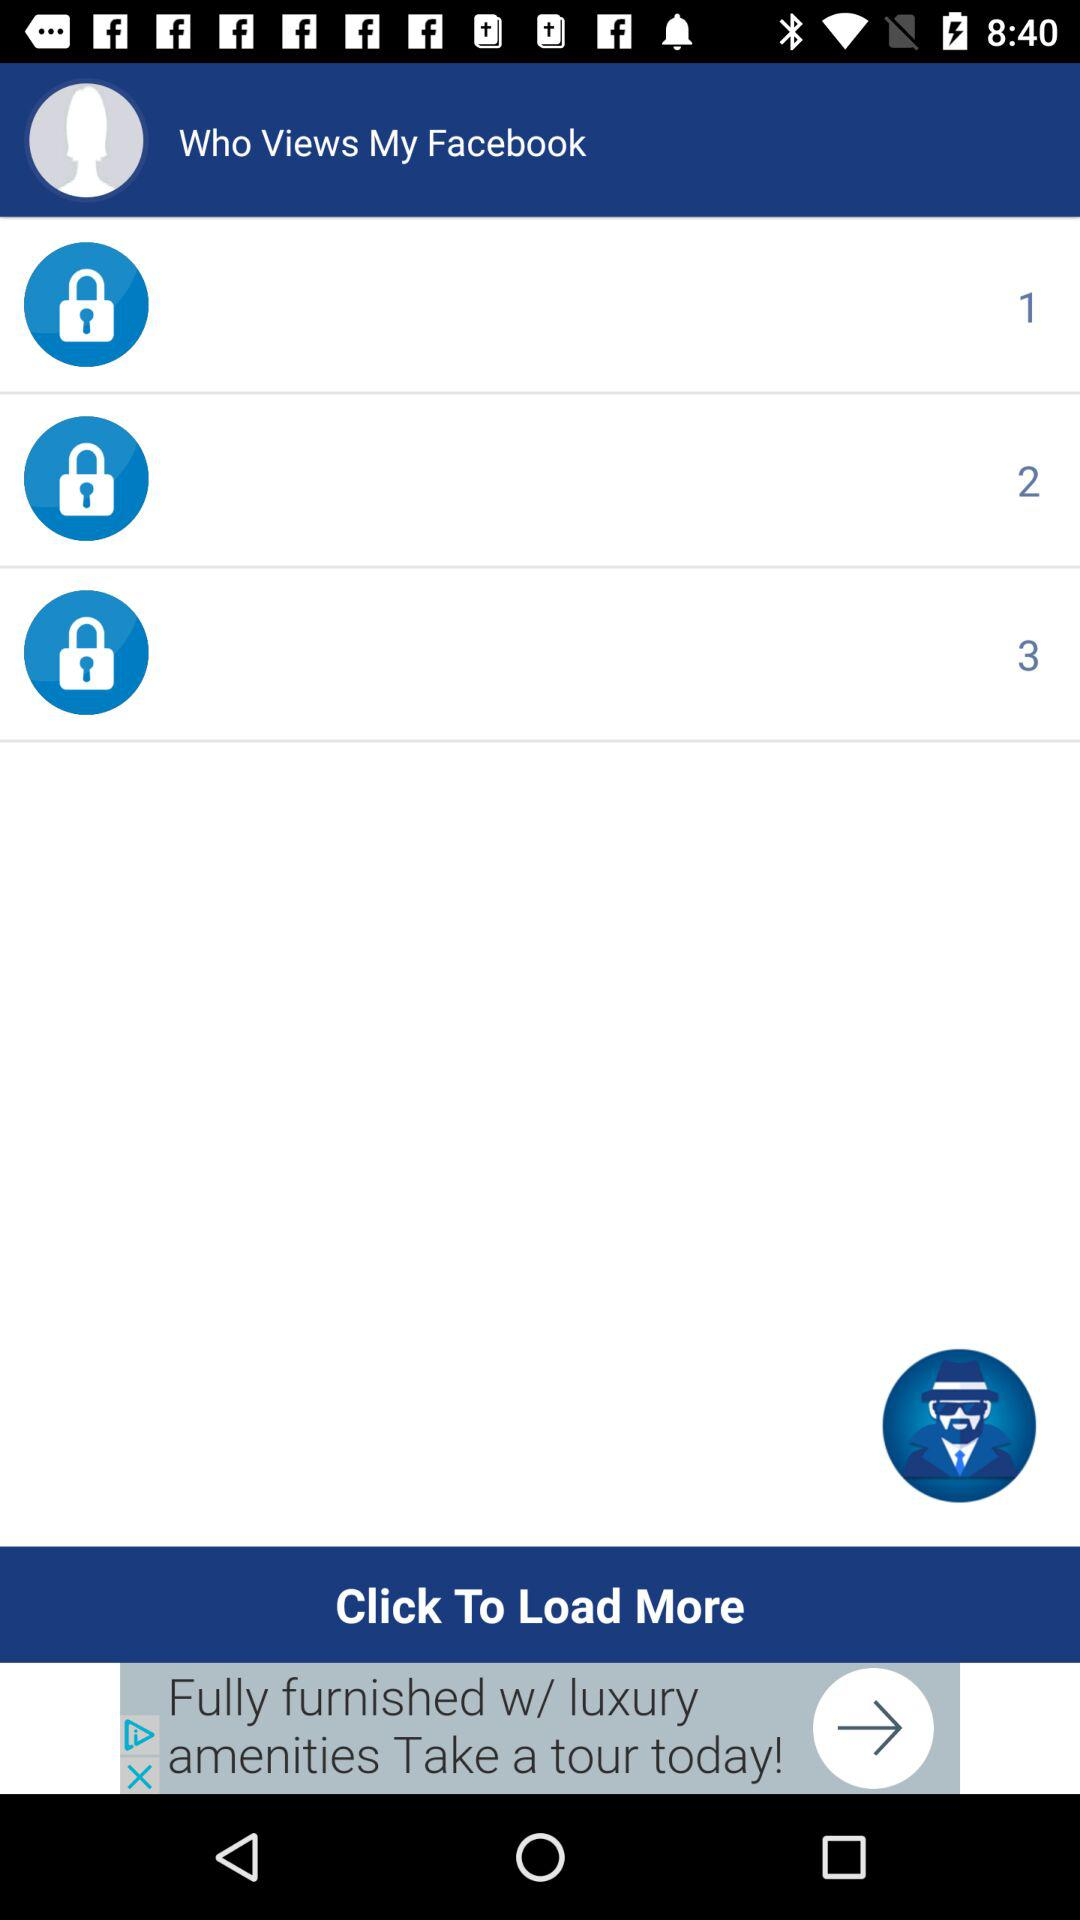How many more can be loaded?
When the provided information is insufficient, respond with <no answer>. <no answer> 